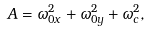<formula> <loc_0><loc_0><loc_500><loc_500>A = \omega _ { 0 x } ^ { 2 } + \omega _ { 0 y } ^ { 2 } + \omega _ { c } ^ { 2 } ,</formula> 